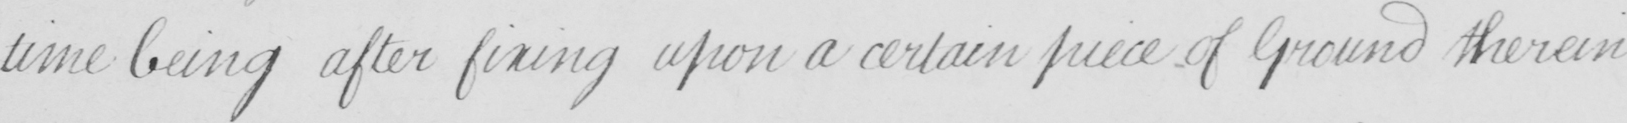Can you tell me what this handwritten text says? time being after fixing upon a certain piece of Ground therein 